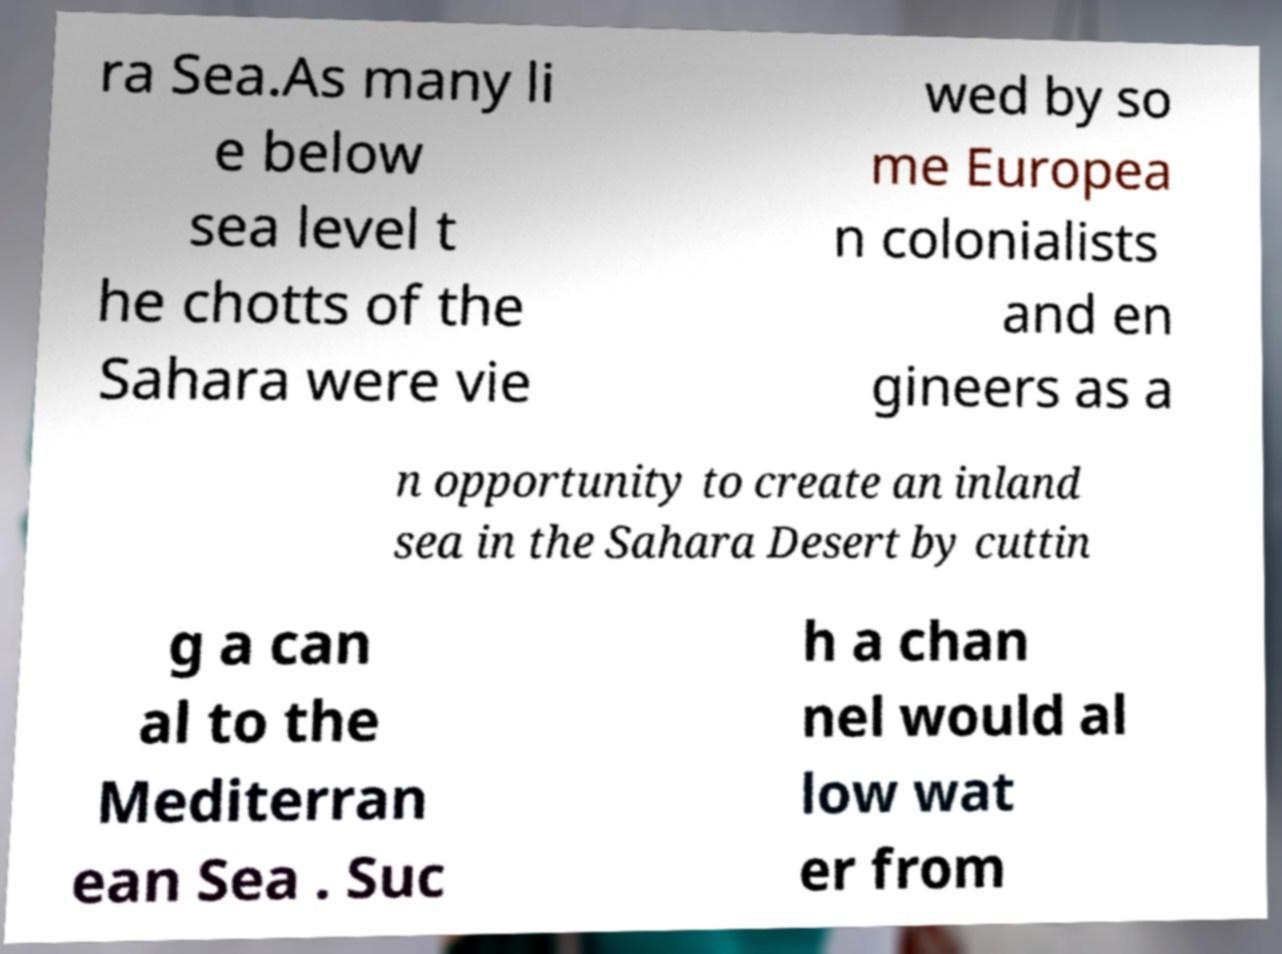Could you assist in decoding the text presented in this image and type it out clearly? ra Sea.As many li e below sea level t he chotts of the Sahara were vie wed by so me Europea n colonialists and en gineers as a n opportunity to create an inland sea in the Sahara Desert by cuttin g a can al to the Mediterran ean Sea . Suc h a chan nel would al low wat er from 